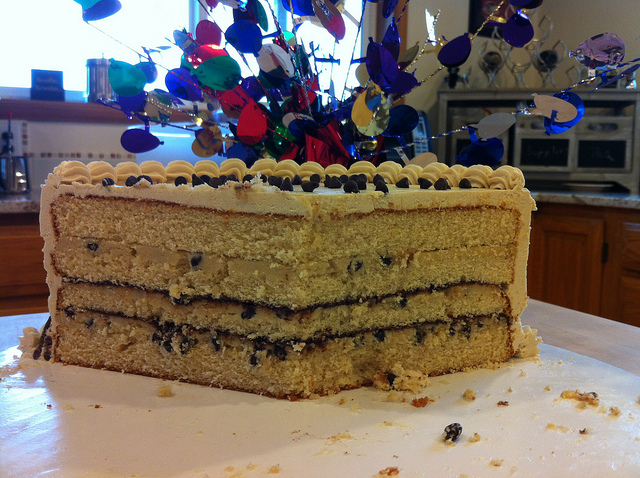<image>What kind of berries on the desert? I am not sure what kind of berries are on the dessert. They could be blueberries or blackberries. What kind of berries on the desert? It is not clear what kind of berries are on the desert. It can be seen blueberries or blackberries. 